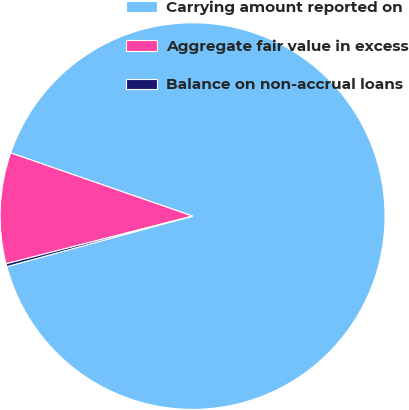<chart> <loc_0><loc_0><loc_500><loc_500><pie_chart><fcel>Carrying amount reported on<fcel>Aggregate fair value in excess<fcel>Balance on non-accrual loans<nl><fcel>90.49%<fcel>9.27%<fcel>0.24%<nl></chart> 